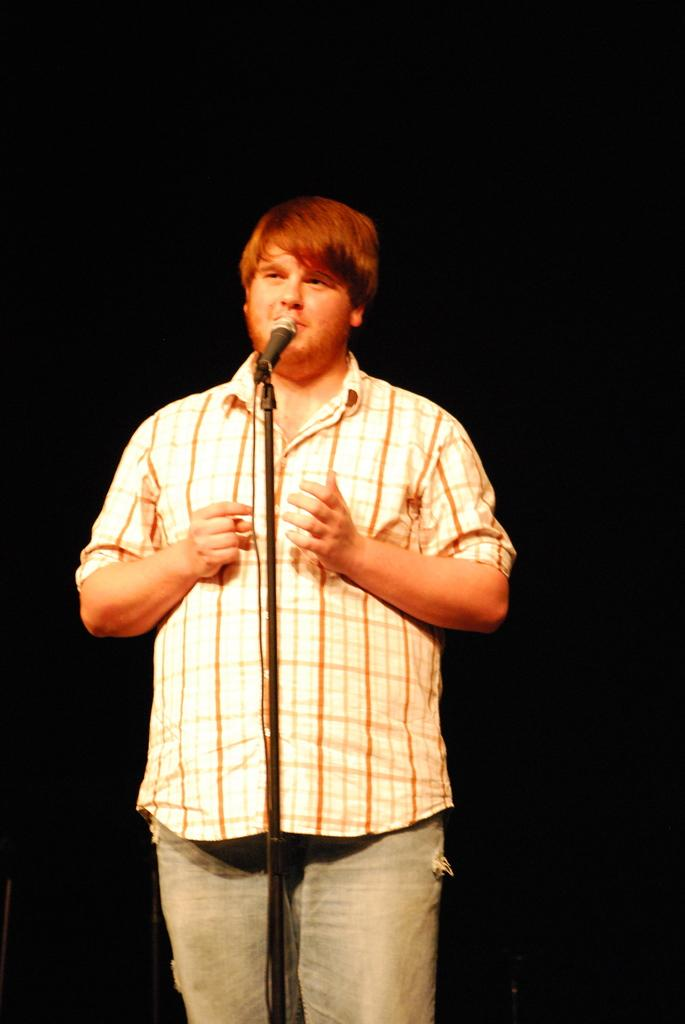What is the lighting condition in the image? The image is taken in the dark. Can you describe the person in the image? There is a person in the image. What is the person doing in the image? The person is standing in front of a microphone. What type of vegetable is the person holding in the image? There is no vegetable present in the image; the person is standing in front of a microphone. Can you describe the facial expression of the tiger in the image? There is no tiger present in the image; the image features a person standing in front of a microphone. 